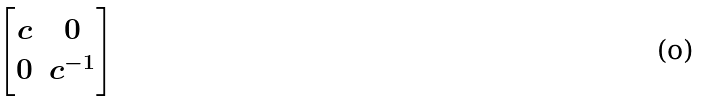Convert formula to latex. <formula><loc_0><loc_0><loc_500><loc_500>\begin{bmatrix} c & 0 \\ 0 & c ^ { - 1 } \end{bmatrix}</formula> 